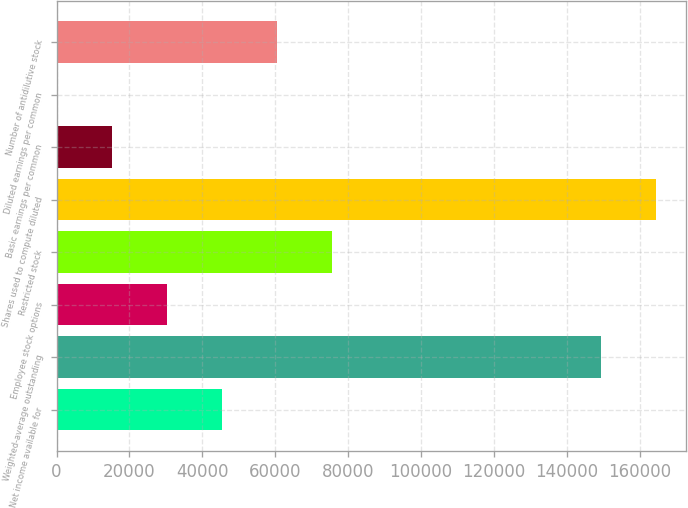<chart> <loc_0><loc_0><loc_500><loc_500><bar_chart><fcel>Net income available for<fcel>Weighted-average outstanding<fcel>Employee stock options<fcel>Restricted stock<fcel>Shares used to compute diluted<fcel>Basic earnings per common<fcel>Diluted earnings per common<fcel>Number of antidilutive stock<nl><fcel>45277.9<fcel>149375<fcel>30186.7<fcel>75460.5<fcel>164466<fcel>15095.4<fcel>4.07<fcel>60369.2<nl></chart> 